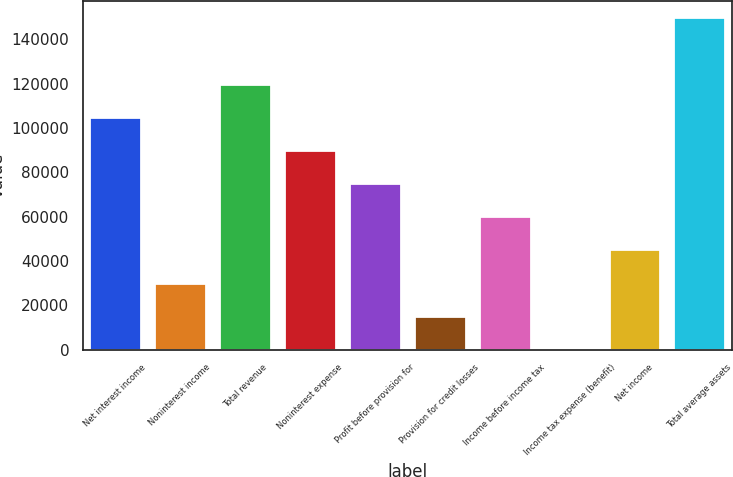<chart> <loc_0><loc_0><loc_500><loc_500><bar_chart><fcel>Net interest income<fcel>Noninterest income<fcel>Total revenue<fcel>Noninterest expense<fcel>Profit before provision for<fcel>Provision for credit losses<fcel>Income before income tax<fcel>Income tax expense (benefit)<fcel>Net income<fcel>Total average assets<nl><fcel>105045<fcel>30198.6<fcel>120014<fcel>90075.8<fcel>75106.5<fcel>15229.3<fcel>60137.2<fcel>260<fcel>45167.9<fcel>149953<nl></chart> 